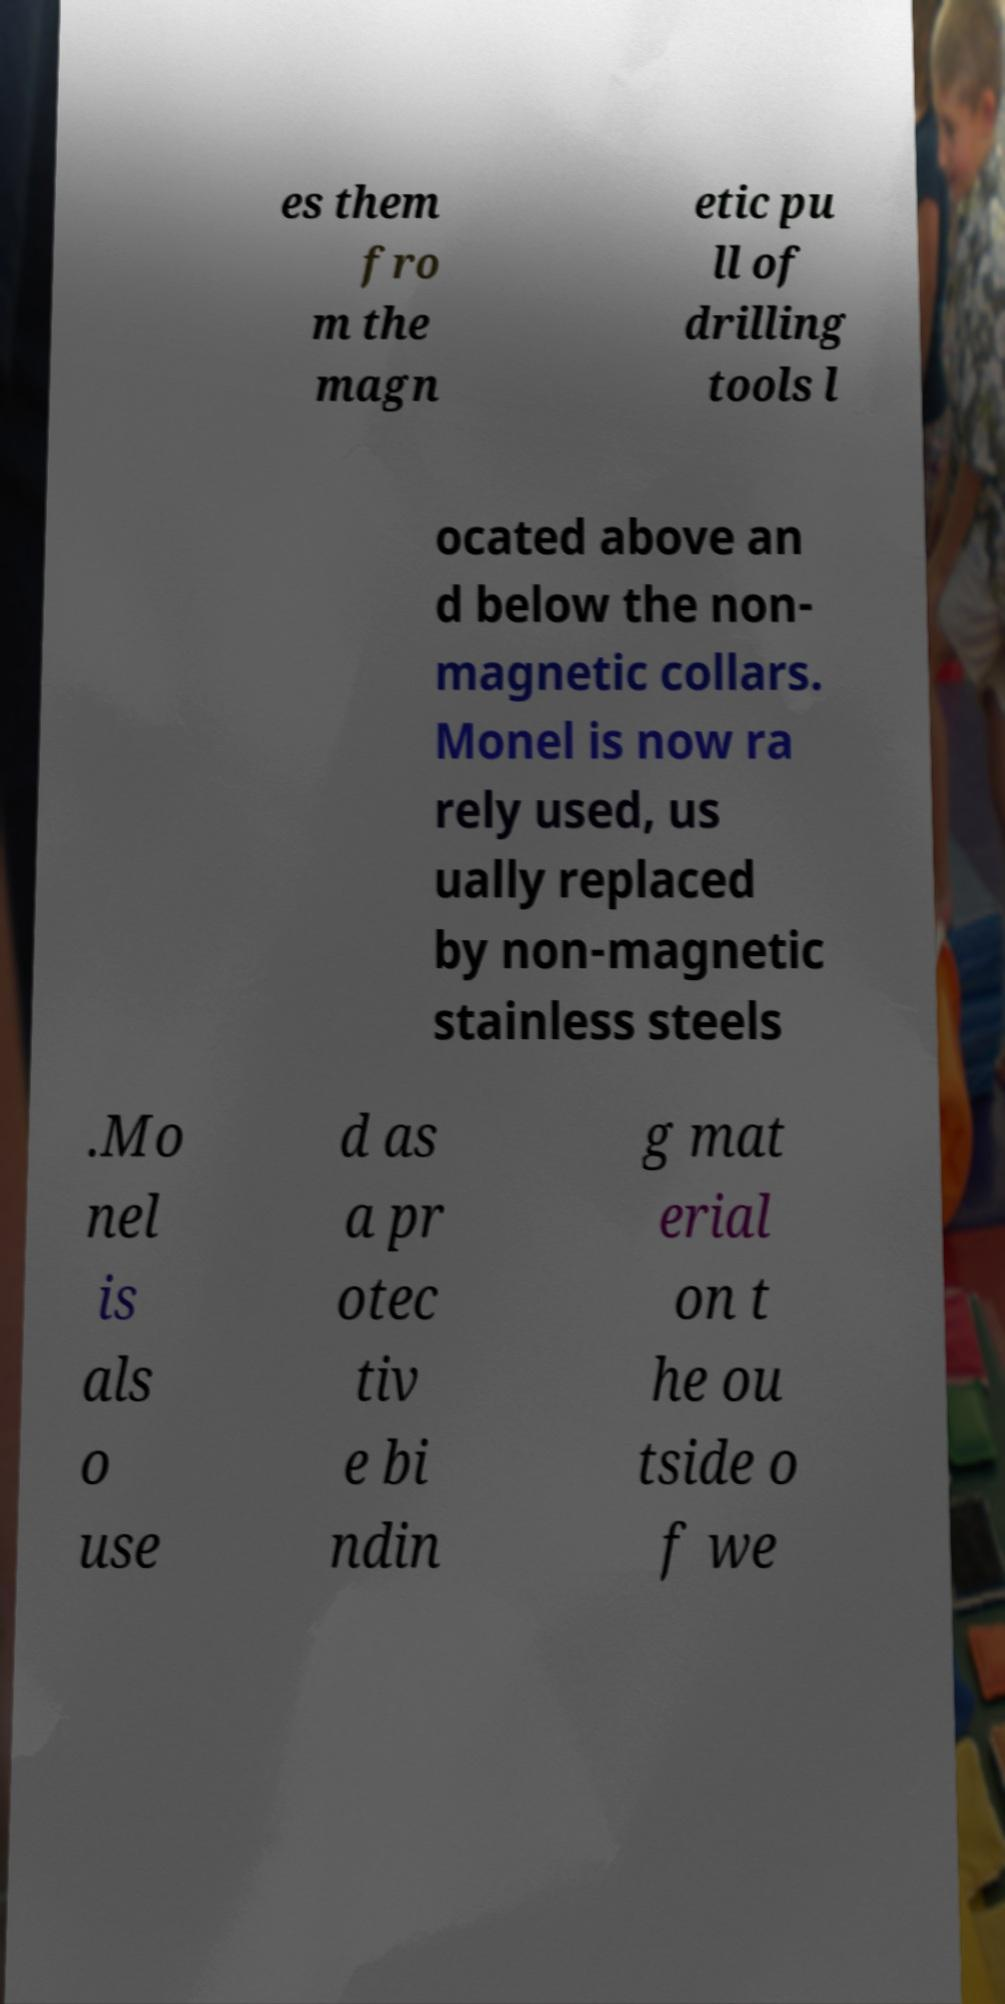What messages or text are displayed in this image? I need them in a readable, typed format. es them fro m the magn etic pu ll of drilling tools l ocated above an d below the non- magnetic collars. Monel is now ra rely used, us ually replaced by non-magnetic stainless steels .Mo nel is als o use d as a pr otec tiv e bi ndin g mat erial on t he ou tside o f we 